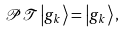<formula> <loc_0><loc_0><loc_500><loc_500>\mathcal { P T } \left | g _ { k } \right \rangle = \left | g _ { k } \right \rangle ,</formula> 